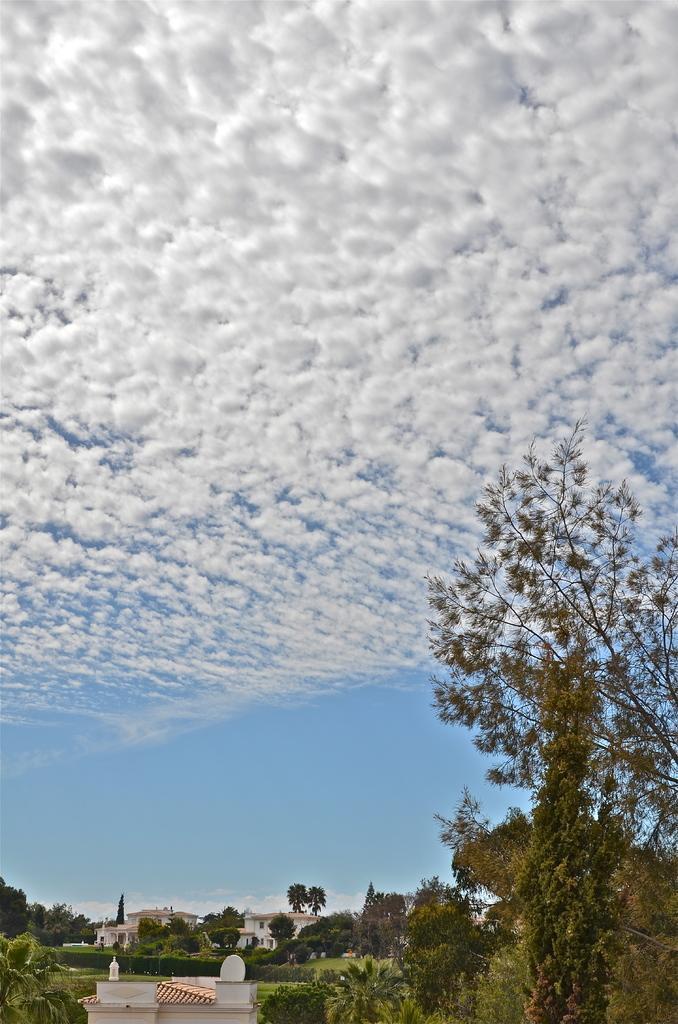Please provide a concise description of this image. In the image I can see some houses, buildings, trees, plants and some clouds to the sky. 